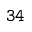<formula> <loc_0><loc_0><loc_500><loc_500>3 4</formula> 